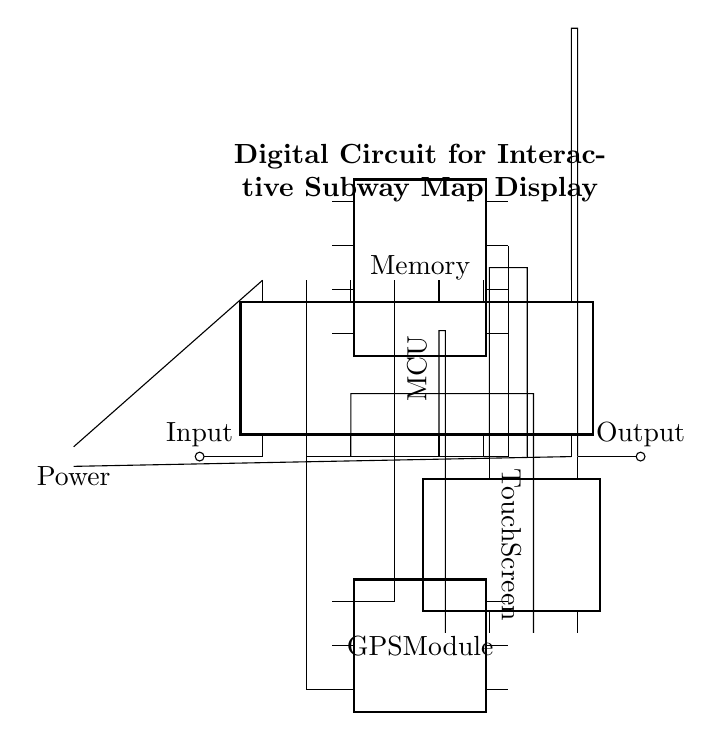What is the main component of this circuit? The main component is the Microcontroller Unit (MCU), as it serves as the central processor that interacts with other components in the circuit.
Answer: Microcontroller Unit How many pins does the touch screen have? The touch screen has 8 pins, which are used for connections to the microcontroller and other circuitry.
Answer: 8 Which component is responsible for processing input data? The microcontroller is responsible for processing input data as it receives signals from various components, like the GPS module and the touch screen.
Answer: Microcontroller What type of component is the GPS module? The GPS module is a dip chip, which indicates it is a type of integrated circuit used for various purposes, particularly location tracking in the subway map display.
Answer: Dip chip How is power supplied to the microcontroller? Power is supplied to the microcontroller via a battery, where positive and negative connections are made to specific pins of the MCU.
Answer: Battery What is the function of the memory component? The memory component stores data needed for the microcontroller to operate effectively, including potentially the subway map information and user inputs.
Answer: Store data How many connections does the microcontroller make to the memory? The microcontroller makes 2 connections to the memory component, which correspond to its pins used for data transfer.
Answer: 2 